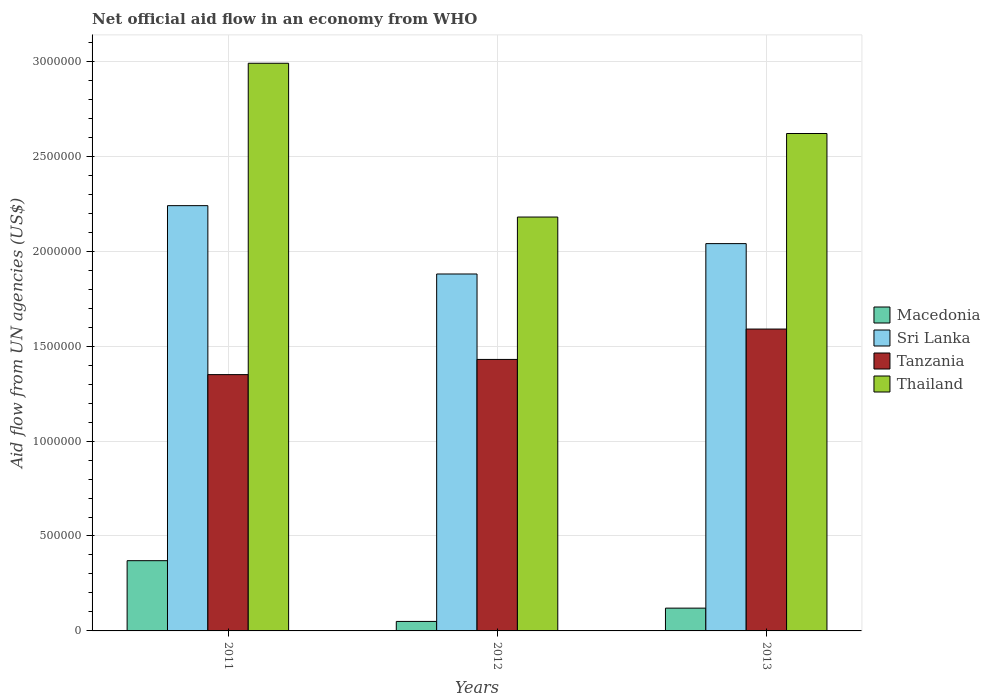How many different coloured bars are there?
Offer a very short reply. 4. How many groups of bars are there?
Keep it short and to the point. 3. Are the number of bars per tick equal to the number of legend labels?
Make the answer very short. Yes. How many bars are there on the 2nd tick from the left?
Your response must be concise. 4. How many bars are there on the 2nd tick from the right?
Your response must be concise. 4. What is the label of the 2nd group of bars from the left?
Provide a succinct answer. 2012. In how many cases, is the number of bars for a given year not equal to the number of legend labels?
Offer a terse response. 0. What is the net official aid flow in Tanzania in 2012?
Give a very brief answer. 1.43e+06. Across all years, what is the maximum net official aid flow in Sri Lanka?
Keep it short and to the point. 2.24e+06. Across all years, what is the minimum net official aid flow in Thailand?
Your response must be concise. 2.18e+06. In which year was the net official aid flow in Macedonia maximum?
Make the answer very short. 2011. In which year was the net official aid flow in Macedonia minimum?
Offer a terse response. 2012. What is the total net official aid flow in Tanzania in the graph?
Your answer should be compact. 4.37e+06. What is the difference between the net official aid flow in Sri Lanka in 2011 and that in 2012?
Make the answer very short. 3.60e+05. What is the difference between the net official aid flow in Thailand in 2011 and the net official aid flow in Macedonia in 2012?
Keep it short and to the point. 2.94e+06. What is the average net official aid flow in Macedonia per year?
Make the answer very short. 1.80e+05. In the year 2011, what is the difference between the net official aid flow in Macedonia and net official aid flow in Sri Lanka?
Make the answer very short. -1.87e+06. Is the net official aid flow in Thailand in 2011 less than that in 2013?
Your answer should be very brief. No. What is the difference between the highest and the lowest net official aid flow in Tanzania?
Provide a short and direct response. 2.40e+05. Is it the case that in every year, the sum of the net official aid flow in Macedonia and net official aid flow in Sri Lanka is greater than the sum of net official aid flow in Tanzania and net official aid flow in Thailand?
Your answer should be compact. No. What does the 1st bar from the left in 2011 represents?
Offer a very short reply. Macedonia. What does the 1st bar from the right in 2011 represents?
Your answer should be very brief. Thailand. Is it the case that in every year, the sum of the net official aid flow in Tanzania and net official aid flow in Macedonia is greater than the net official aid flow in Thailand?
Keep it short and to the point. No. Are all the bars in the graph horizontal?
Your answer should be very brief. No. How many years are there in the graph?
Offer a terse response. 3. Are the values on the major ticks of Y-axis written in scientific E-notation?
Offer a terse response. No. Does the graph contain any zero values?
Ensure brevity in your answer.  No. Where does the legend appear in the graph?
Your answer should be compact. Center right. How many legend labels are there?
Your response must be concise. 4. What is the title of the graph?
Your answer should be compact. Net official aid flow in an economy from WHO. What is the label or title of the Y-axis?
Provide a succinct answer. Aid flow from UN agencies (US$). What is the Aid flow from UN agencies (US$) in Sri Lanka in 2011?
Your answer should be compact. 2.24e+06. What is the Aid flow from UN agencies (US$) of Tanzania in 2011?
Ensure brevity in your answer.  1.35e+06. What is the Aid flow from UN agencies (US$) of Thailand in 2011?
Provide a short and direct response. 2.99e+06. What is the Aid flow from UN agencies (US$) in Macedonia in 2012?
Keep it short and to the point. 5.00e+04. What is the Aid flow from UN agencies (US$) in Sri Lanka in 2012?
Give a very brief answer. 1.88e+06. What is the Aid flow from UN agencies (US$) of Tanzania in 2012?
Provide a succinct answer. 1.43e+06. What is the Aid flow from UN agencies (US$) of Thailand in 2012?
Your response must be concise. 2.18e+06. What is the Aid flow from UN agencies (US$) of Macedonia in 2013?
Provide a succinct answer. 1.20e+05. What is the Aid flow from UN agencies (US$) of Sri Lanka in 2013?
Provide a succinct answer. 2.04e+06. What is the Aid flow from UN agencies (US$) of Tanzania in 2013?
Ensure brevity in your answer.  1.59e+06. What is the Aid flow from UN agencies (US$) in Thailand in 2013?
Keep it short and to the point. 2.62e+06. Across all years, what is the maximum Aid flow from UN agencies (US$) of Macedonia?
Offer a very short reply. 3.70e+05. Across all years, what is the maximum Aid flow from UN agencies (US$) in Sri Lanka?
Provide a short and direct response. 2.24e+06. Across all years, what is the maximum Aid flow from UN agencies (US$) of Tanzania?
Give a very brief answer. 1.59e+06. Across all years, what is the maximum Aid flow from UN agencies (US$) in Thailand?
Keep it short and to the point. 2.99e+06. Across all years, what is the minimum Aid flow from UN agencies (US$) of Macedonia?
Your answer should be very brief. 5.00e+04. Across all years, what is the minimum Aid flow from UN agencies (US$) of Sri Lanka?
Your answer should be very brief. 1.88e+06. Across all years, what is the minimum Aid flow from UN agencies (US$) in Tanzania?
Ensure brevity in your answer.  1.35e+06. Across all years, what is the minimum Aid flow from UN agencies (US$) of Thailand?
Provide a succinct answer. 2.18e+06. What is the total Aid flow from UN agencies (US$) of Macedonia in the graph?
Make the answer very short. 5.40e+05. What is the total Aid flow from UN agencies (US$) in Sri Lanka in the graph?
Keep it short and to the point. 6.16e+06. What is the total Aid flow from UN agencies (US$) of Tanzania in the graph?
Provide a short and direct response. 4.37e+06. What is the total Aid flow from UN agencies (US$) of Thailand in the graph?
Offer a very short reply. 7.79e+06. What is the difference between the Aid flow from UN agencies (US$) in Macedonia in 2011 and that in 2012?
Keep it short and to the point. 3.20e+05. What is the difference between the Aid flow from UN agencies (US$) of Thailand in 2011 and that in 2012?
Offer a terse response. 8.10e+05. What is the difference between the Aid flow from UN agencies (US$) in Sri Lanka in 2011 and that in 2013?
Offer a very short reply. 2.00e+05. What is the difference between the Aid flow from UN agencies (US$) of Tanzania in 2011 and that in 2013?
Provide a short and direct response. -2.40e+05. What is the difference between the Aid flow from UN agencies (US$) in Thailand in 2011 and that in 2013?
Your answer should be very brief. 3.70e+05. What is the difference between the Aid flow from UN agencies (US$) of Macedonia in 2012 and that in 2013?
Keep it short and to the point. -7.00e+04. What is the difference between the Aid flow from UN agencies (US$) of Thailand in 2012 and that in 2013?
Provide a succinct answer. -4.40e+05. What is the difference between the Aid flow from UN agencies (US$) of Macedonia in 2011 and the Aid flow from UN agencies (US$) of Sri Lanka in 2012?
Keep it short and to the point. -1.51e+06. What is the difference between the Aid flow from UN agencies (US$) of Macedonia in 2011 and the Aid flow from UN agencies (US$) of Tanzania in 2012?
Ensure brevity in your answer.  -1.06e+06. What is the difference between the Aid flow from UN agencies (US$) of Macedonia in 2011 and the Aid flow from UN agencies (US$) of Thailand in 2012?
Offer a very short reply. -1.81e+06. What is the difference between the Aid flow from UN agencies (US$) of Sri Lanka in 2011 and the Aid flow from UN agencies (US$) of Tanzania in 2012?
Provide a succinct answer. 8.10e+05. What is the difference between the Aid flow from UN agencies (US$) of Tanzania in 2011 and the Aid flow from UN agencies (US$) of Thailand in 2012?
Provide a short and direct response. -8.30e+05. What is the difference between the Aid flow from UN agencies (US$) in Macedonia in 2011 and the Aid flow from UN agencies (US$) in Sri Lanka in 2013?
Keep it short and to the point. -1.67e+06. What is the difference between the Aid flow from UN agencies (US$) of Macedonia in 2011 and the Aid flow from UN agencies (US$) of Tanzania in 2013?
Offer a terse response. -1.22e+06. What is the difference between the Aid flow from UN agencies (US$) in Macedonia in 2011 and the Aid flow from UN agencies (US$) in Thailand in 2013?
Offer a terse response. -2.25e+06. What is the difference between the Aid flow from UN agencies (US$) in Sri Lanka in 2011 and the Aid flow from UN agencies (US$) in Tanzania in 2013?
Your response must be concise. 6.50e+05. What is the difference between the Aid flow from UN agencies (US$) of Sri Lanka in 2011 and the Aid flow from UN agencies (US$) of Thailand in 2013?
Your answer should be very brief. -3.80e+05. What is the difference between the Aid flow from UN agencies (US$) in Tanzania in 2011 and the Aid flow from UN agencies (US$) in Thailand in 2013?
Your response must be concise. -1.27e+06. What is the difference between the Aid flow from UN agencies (US$) in Macedonia in 2012 and the Aid flow from UN agencies (US$) in Sri Lanka in 2013?
Offer a very short reply. -1.99e+06. What is the difference between the Aid flow from UN agencies (US$) in Macedonia in 2012 and the Aid flow from UN agencies (US$) in Tanzania in 2013?
Your answer should be compact. -1.54e+06. What is the difference between the Aid flow from UN agencies (US$) in Macedonia in 2012 and the Aid flow from UN agencies (US$) in Thailand in 2013?
Keep it short and to the point. -2.57e+06. What is the difference between the Aid flow from UN agencies (US$) in Sri Lanka in 2012 and the Aid flow from UN agencies (US$) in Tanzania in 2013?
Keep it short and to the point. 2.90e+05. What is the difference between the Aid flow from UN agencies (US$) of Sri Lanka in 2012 and the Aid flow from UN agencies (US$) of Thailand in 2013?
Keep it short and to the point. -7.40e+05. What is the difference between the Aid flow from UN agencies (US$) of Tanzania in 2012 and the Aid flow from UN agencies (US$) of Thailand in 2013?
Ensure brevity in your answer.  -1.19e+06. What is the average Aid flow from UN agencies (US$) of Sri Lanka per year?
Your response must be concise. 2.05e+06. What is the average Aid flow from UN agencies (US$) of Tanzania per year?
Provide a succinct answer. 1.46e+06. What is the average Aid flow from UN agencies (US$) in Thailand per year?
Your answer should be very brief. 2.60e+06. In the year 2011, what is the difference between the Aid flow from UN agencies (US$) of Macedonia and Aid flow from UN agencies (US$) of Sri Lanka?
Give a very brief answer. -1.87e+06. In the year 2011, what is the difference between the Aid flow from UN agencies (US$) of Macedonia and Aid flow from UN agencies (US$) of Tanzania?
Keep it short and to the point. -9.80e+05. In the year 2011, what is the difference between the Aid flow from UN agencies (US$) of Macedonia and Aid flow from UN agencies (US$) of Thailand?
Keep it short and to the point. -2.62e+06. In the year 2011, what is the difference between the Aid flow from UN agencies (US$) in Sri Lanka and Aid flow from UN agencies (US$) in Tanzania?
Keep it short and to the point. 8.90e+05. In the year 2011, what is the difference between the Aid flow from UN agencies (US$) in Sri Lanka and Aid flow from UN agencies (US$) in Thailand?
Your answer should be very brief. -7.50e+05. In the year 2011, what is the difference between the Aid flow from UN agencies (US$) in Tanzania and Aid flow from UN agencies (US$) in Thailand?
Your answer should be compact. -1.64e+06. In the year 2012, what is the difference between the Aid flow from UN agencies (US$) of Macedonia and Aid flow from UN agencies (US$) of Sri Lanka?
Keep it short and to the point. -1.83e+06. In the year 2012, what is the difference between the Aid flow from UN agencies (US$) of Macedonia and Aid flow from UN agencies (US$) of Tanzania?
Give a very brief answer. -1.38e+06. In the year 2012, what is the difference between the Aid flow from UN agencies (US$) in Macedonia and Aid flow from UN agencies (US$) in Thailand?
Your response must be concise. -2.13e+06. In the year 2012, what is the difference between the Aid flow from UN agencies (US$) of Sri Lanka and Aid flow from UN agencies (US$) of Tanzania?
Your answer should be very brief. 4.50e+05. In the year 2012, what is the difference between the Aid flow from UN agencies (US$) in Tanzania and Aid flow from UN agencies (US$) in Thailand?
Your answer should be compact. -7.50e+05. In the year 2013, what is the difference between the Aid flow from UN agencies (US$) in Macedonia and Aid flow from UN agencies (US$) in Sri Lanka?
Your answer should be very brief. -1.92e+06. In the year 2013, what is the difference between the Aid flow from UN agencies (US$) of Macedonia and Aid flow from UN agencies (US$) of Tanzania?
Your response must be concise. -1.47e+06. In the year 2013, what is the difference between the Aid flow from UN agencies (US$) of Macedonia and Aid flow from UN agencies (US$) of Thailand?
Make the answer very short. -2.50e+06. In the year 2013, what is the difference between the Aid flow from UN agencies (US$) in Sri Lanka and Aid flow from UN agencies (US$) in Thailand?
Your answer should be compact. -5.80e+05. In the year 2013, what is the difference between the Aid flow from UN agencies (US$) of Tanzania and Aid flow from UN agencies (US$) of Thailand?
Make the answer very short. -1.03e+06. What is the ratio of the Aid flow from UN agencies (US$) of Sri Lanka in 2011 to that in 2012?
Your answer should be very brief. 1.19. What is the ratio of the Aid flow from UN agencies (US$) in Tanzania in 2011 to that in 2012?
Your answer should be compact. 0.94. What is the ratio of the Aid flow from UN agencies (US$) of Thailand in 2011 to that in 2012?
Make the answer very short. 1.37. What is the ratio of the Aid flow from UN agencies (US$) in Macedonia in 2011 to that in 2013?
Offer a terse response. 3.08. What is the ratio of the Aid flow from UN agencies (US$) in Sri Lanka in 2011 to that in 2013?
Give a very brief answer. 1.1. What is the ratio of the Aid flow from UN agencies (US$) in Tanzania in 2011 to that in 2013?
Provide a succinct answer. 0.85. What is the ratio of the Aid flow from UN agencies (US$) of Thailand in 2011 to that in 2013?
Your answer should be very brief. 1.14. What is the ratio of the Aid flow from UN agencies (US$) of Macedonia in 2012 to that in 2013?
Offer a very short reply. 0.42. What is the ratio of the Aid flow from UN agencies (US$) in Sri Lanka in 2012 to that in 2013?
Your response must be concise. 0.92. What is the ratio of the Aid flow from UN agencies (US$) of Tanzania in 2012 to that in 2013?
Offer a very short reply. 0.9. What is the ratio of the Aid flow from UN agencies (US$) of Thailand in 2012 to that in 2013?
Provide a short and direct response. 0.83. What is the difference between the highest and the second highest Aid flow from UN agencies (US$) of Macedonia?
Keep it short and to the point. 2.50e+05. What is the difference between the highest and the second highest Aid flow from UN agencies (US$) of Sri Lanka?
Make the answer very short. 2.00e+05. What is the difference between the highest and the second highest Aid flow from UN agencies (US$) in Tanzania?
Provide a short and direct response. 1.60e+05. What is the difference between the highest and the second highest Aid flow from UN agencies (US$) in Thailand?
Offer a very short reply. 3.70e+05. What is the difference between the highest and the lowest Aid flow from UN agencies (US$) in Macedonia?
Provide a short and direct response. 3.20e+05. What is the difference between the highest and the lowest Aid flow from UN agencies (US$) in Tanzania?
Give a very brief answer. 2.40e+05. What is the difference between the highest and the lowest Aid flow from UN agencies (US$) in Thailand?
Your answer should be very brief. 8.10e+05. 